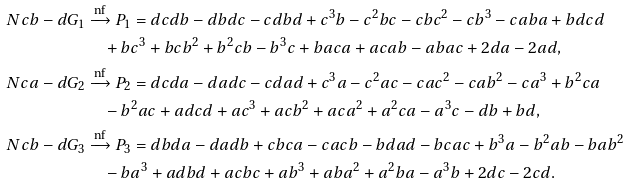<formula> <loc_0><loc_0><loc_500><loc_500>N c b - d G _ { 1 } & \xrightarrow { \text {nf} } P _ { 1 } = d c d b - d b d c - c d b d + c ^ { 3 } b - c ^ { 2 } b c - c b c ^ { 2 } - c b ^ { 3 } - c a b a + b d c d \\ & \quad + b c ^ { 3 } + b c b ^ { 2 } + b ^ { 2 } c b - b ^ { 3 } c + b a c a + a c a b - a b a c + 2 d a - 2 a d , \\ N c a - d G _ { 2 } & \xrightarrow { \text {nf} } P _ { 2 } = d c d a - d a d c - c d a d + c ^ { 3 } a - c ^ { 2 } a c - c a c ^ { 2 } - c a b ^ { 2 } - c a ^ { 3 } + b ^ { 2 } c a \\ & \quad - b ^ { 2 } a c + a d c d + a c ^ { 3 } + a c b ^ { 2 } + a c a ^ { 2 } + a ^ { 2 } c a - a ^ { 3 } c - d b + b d , \\ N c b - d G _ { 3 } & \xrightarrow { \text {nf} } P _ { 3 } = d b d a - d a d b + c b c a - c a c b - b d a d - b c a c + b ^ { 3 } a - b ^ { 2 } a b - b a b ^ { 2 } \\ & \quad - b a ^ { 3 } + a d b d + a c b c + a b ^ { 3 } + a b a ^ { 2 } + a ^ { 2 } b a - a ^ { 3 } b + 2 d c - 2 c d .</formula> 